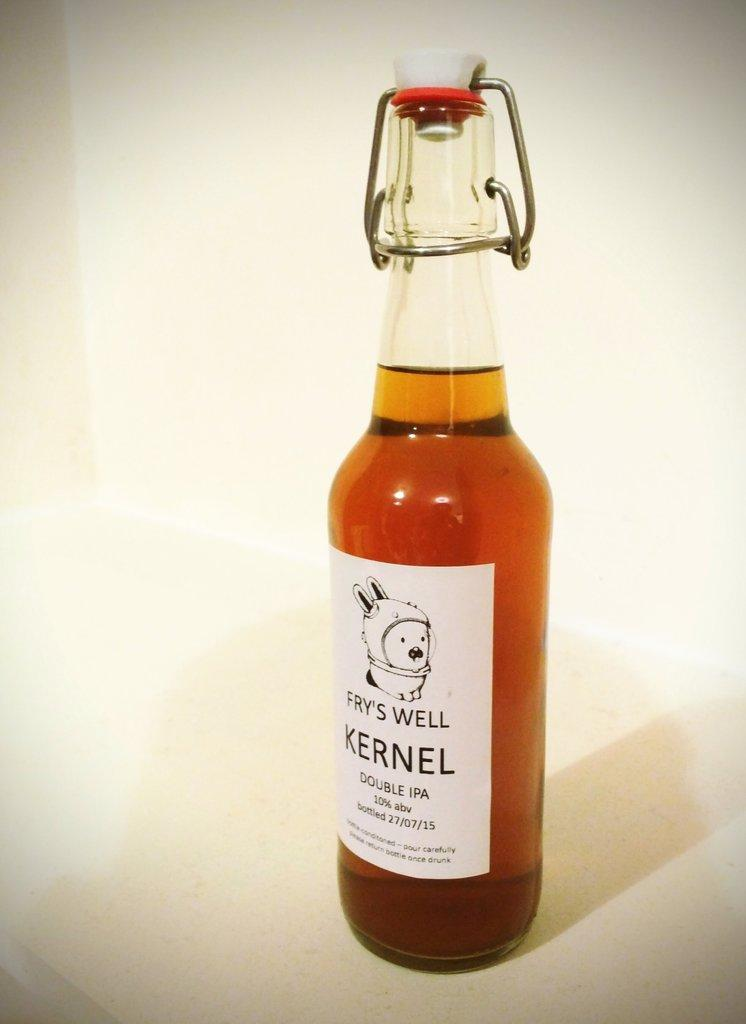<image>
Write a terse but informative summary of the picture. a bottle says kernel and also fry's well 